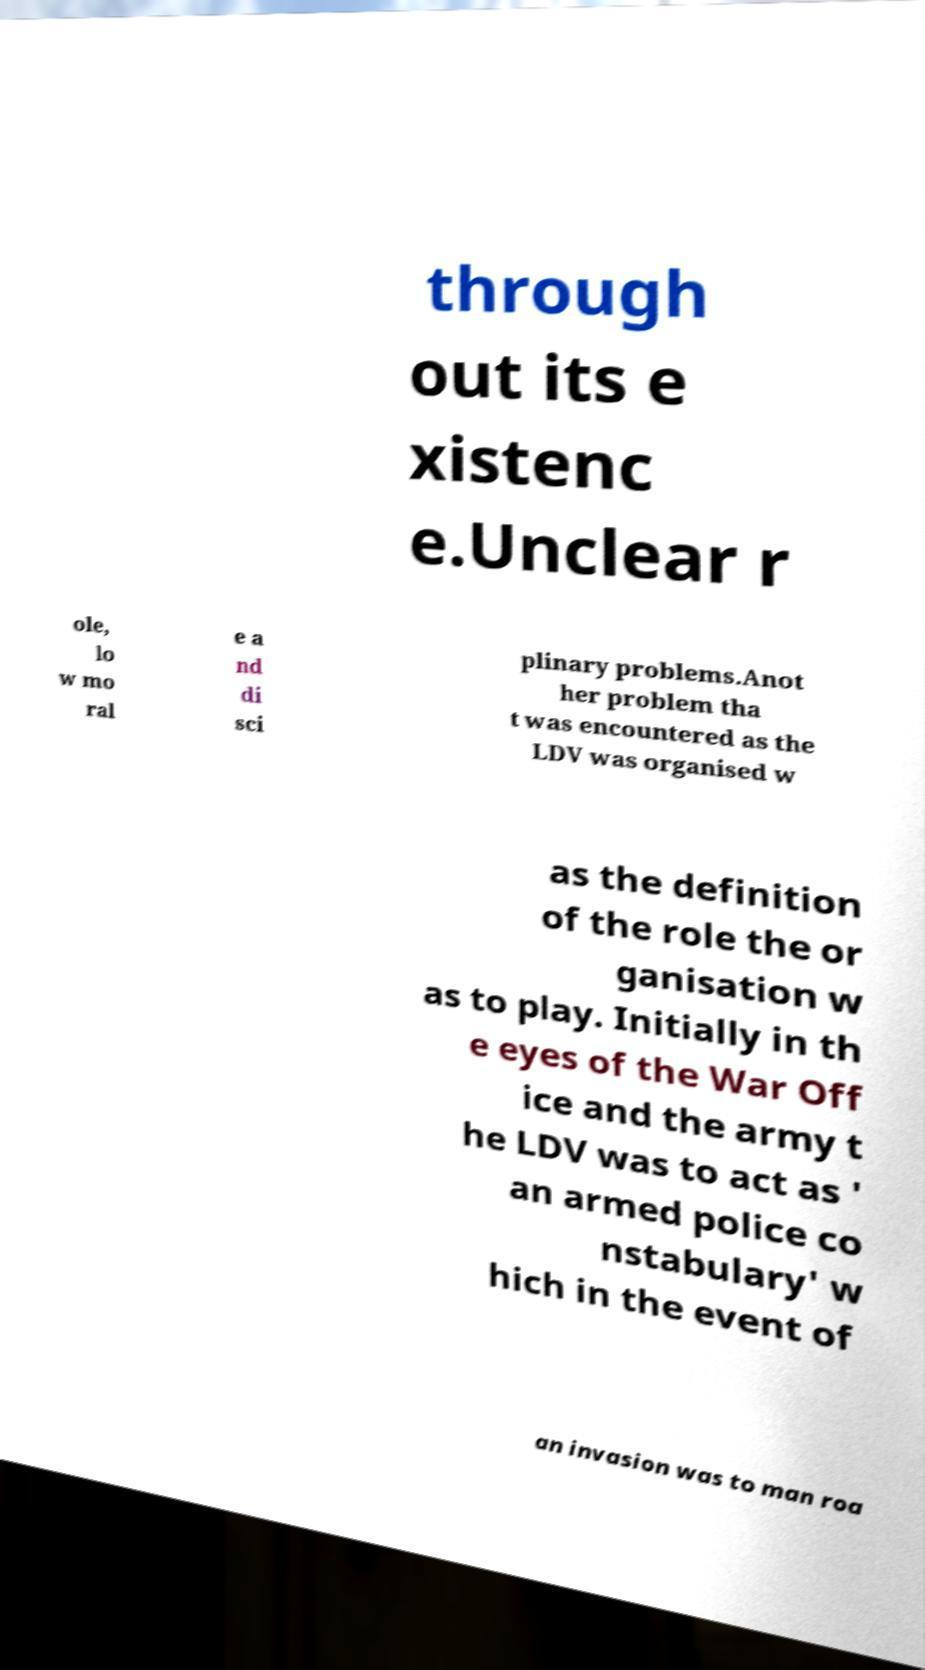There's text embedded in this image that I need extracted. Can you transcribe it verbatim? through out its e xistenc e.Unclear r ole, lo w mo ral e a nd di sci plinary problems.Anot her problem tha t was encountered as the LDV was organised w as the definition of the role the or ganisation w as to play. Initially in th e eyes of the War Off ice and the army t he LDV was to act as ' an armed police co nstabulary' w hich in the event of an invasion was to man roa 